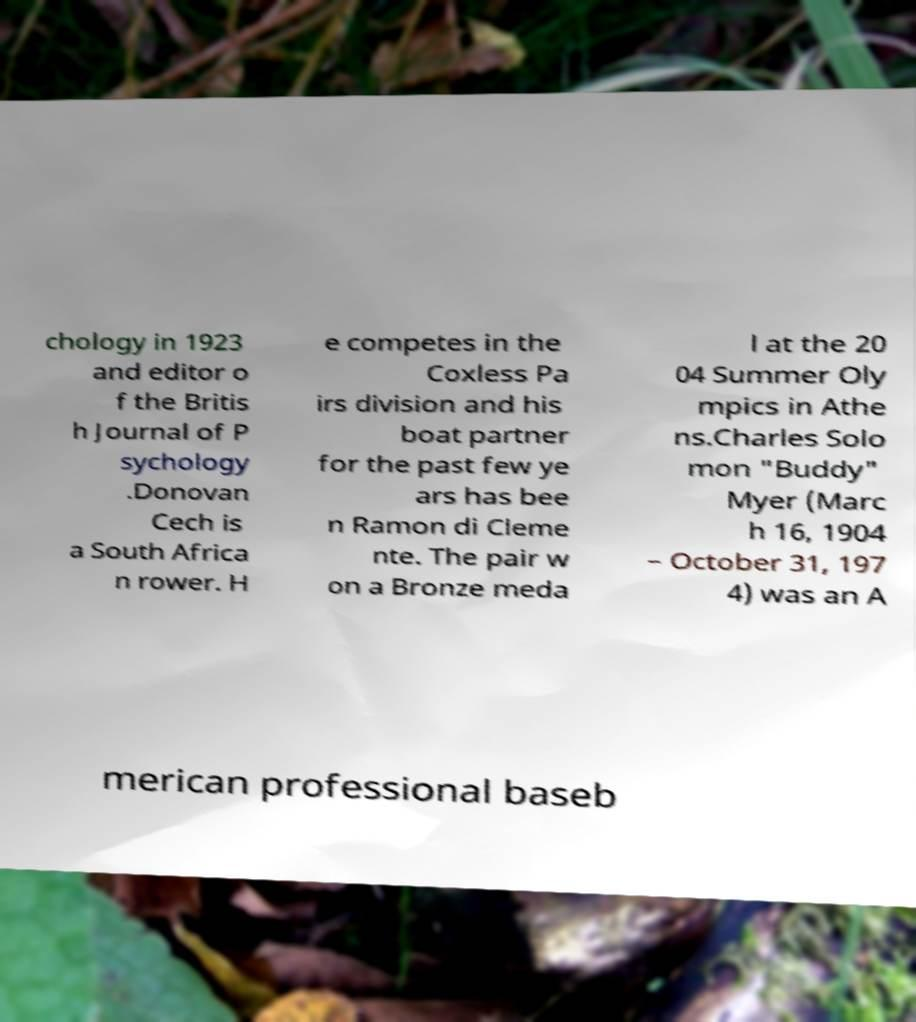Can you read and provide the text displayed in the image?This photo seems to have some interesting text. Can you extract and type it out for me? chology in 1923 and editor o f the Britis h Journal of P sychology .Donovan Cech is a South Africa n rower. H e competes in the Coxless Pa irs division and his boat partner for the past few ye ars has bee n Ramon di Cleme nte. The pair w on a Bronze meda l at the 20 04 Summer Oly mpics in Athe ns.Charles Solo mon "Buddy" Myer (Marc h 16, 1904 – October 31, 197 4) was an A merican professional baseb 